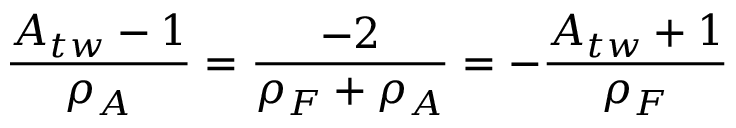<formula> <loc_0><loc_0><loc_500><loc_500>\frac { A _ { t w } - 1 } { \rho _ { A } } = \frac { - 2 } { \rho _ { F } + \rho _ { A } } = - \frac { A _ { t w } + 1 } { \rho _ { F } }</formula> 